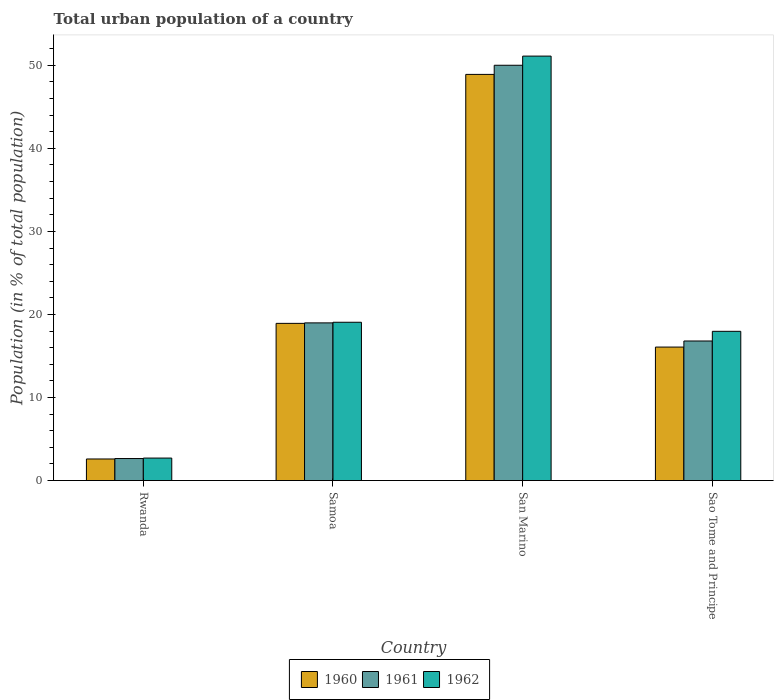How many groups of bars are there?
Your answer should be very brief. 4. How many bars are there on the 1st tick from the left?
Provide a succinct answer. 3. How many bars are there on the 4th tick from the right?
Provide a succinct answer. 3. What is the label of the 2nd group of bars from the left?
Your answer should be compact. Samoa. In how many cases, is the number of bars for a given country not equal to the number of legend labels?
Ensure brevity in your answer.  0. What is the urban population in 1962 in Samoa?
Give a very brief answer. 19.06. Across all countries, what is the maximum urban population in 1960?
Your response must be concise. 48.9. Across all countries, what is the minimum urban population in 1961?
Your response must be concise. 2.65. In which country was the urban population in 1960 maximum?
Keep it short and to the point. San Marino. In which country was the urban population in 1960 minimum?
Keep it short and to the point. Rwanda. What is the total urban population in 1960 in the graph?
Give a very brief answer. 86.5. What is the difference between the urban population in 1962 in Samoa and that in Sao Tome and Principe?
Your response must be concise. 1.09. What is the difference between the urban population in 1962 in Samoa and the urban population in 1961 in Rwanda?
Offer a terse response. 16.41. What is the average urban population in 1962 per country?
Keep it short and to the point. 22.71. What is the difference between the urban population of/in 1961 and urban population of/in 1962 in San Marino?
Give a very brief answer. -1.1. What is the ratio of the urban population in 1960 in Samoa to that in Sao Tome and Principe?
Your response must be concise. 1.18. Is the difference between the urban population in 1961 in Rwanda and Sao Tome and Principe greater than the difference between the urban population in 1962 in Rwanda and Sao Tome and Principe?
Keep it short and to the point. Yes. What is the difference between the highest and the second highest urban population in 1961?
Offer a very short reply. -33.2. What is the difference between the highest and the lowest urban population in 1960?
Ensure brevity in your answer.  46.3. Is the sum of the urban population in 1961 in Rwanda and Sao Tome and Principe greater than the maximum urban population in 1962 across all countries?
Ensure brevity in your answer.  No. What does the 3rd bar from the left in Sao Tome and Principe represents?
Your response must be concise. 1962. Does the graph contain any zero values?
Offer a very short reply. No. Does the graph contain grids?
Your answer should be compact. No. Where does the legend appear in the graph?
Give a very brief answer. Bottom center. How many legend labels are there?
Offer a very short reply. 3. How are the legend labels stacked?
Provide a succinct answer. Horizontal. What is the title of the graph?
Your response must be concise. Total urban population of a country. What is the label or title of the X-axis?
Your answer should be compact. Country. What is the label or title of the Y-axis?
Provide a succinct answer. Population (in % of total population). What is the Population (in % of total population) in 1960 in Rwanda?
Provide a succinct answer. 2.6. What is the Population (in % of total population) in 1961 in Rwanda?
Provide a succinct answer. 2.65. What is the Population (in % of total population) of 1962 in Rwanda?
Ensure brevity in your answer.  2.71. What is the Population (in % of total population) in 1960 in Samoa?
Keep it short and to the point. 18.93. What is the Population (in % of total population) in 1961 in Samoa?
Provide a succinct answer. 18.99. What is the Population (in % of total population) in 1962 in Samoa?
Offer a terse response. 19.06. What is the Population (in % of total population) of 1960 in San Marino?
Your response must be concise. 48.9. What is the Population (in % of total population) of 1961 in San Marino?
Make the answer very short. 50. What is the Population (in % of total population) in 1962 in San Marino?
Keep it short and to the point. 51.1. What is the Population (in % of total population) in 1960 in Sao Tome and Principe?
Provide a short and direct response. 16.07. What is the Population (in % of total population) in 1961 in Sao Tome and Principe?
Give a very brief answer. 16.8. What is the Population (in % of total population) in 1962 in Sao Tome and Principe?
Your answer should be very brief. 17.97. Across all countries, what is the maximum Population (in % of total population) of 1960?
Give a very brief answer. 48.9. Across all countries, what is the maximum Population (in % of total population) in 1961?
Ensure brevity in your answer.  50. Across all countries, what is the maximum Population (in % of total population) in 1962?
Offer a very short reply. 51.1. Across all countries, what is the minimum Population (in % of total population) in 1961?
Keep it short and to the point. 2.65. Across all countries, what is the minimum Population (in % of total population) of 1962?
Provide a short and direct response. 2.71. What is the total Population (in % of total population) in 1960 in the graph?
Provide a short and direct response. 86.5. What is the total Population (in % of total population) in 1961 in the graph?
Provide a succinct answer. 88.45. What is the total Population (in % of total population) of 1962 in the graph?
Make the answer very short. 90.84. What is the difference between the Population (in % of total population) of 1960 in Rwanda and that in Samoa?
Provide a short and direct response. -16.33. What is the difference between the Population (in % of total population) in 1961 in Rwanda and that in Samoa?
Your response must be concise. -16.33. What is the difference between the Population (in % of total population) in 1962 in Rwanda and that in Samoa?
Offer a terse response. -16.35. What is the difference between the Population (in % of total population) of 1960 in Rwanda and that in San Marino?
Provide a short and direct response. -46.3. What is the difference between the Population (in % of total population) of 1961 in Rwanda and that in San Marino?
Your response must be concise. -47.35. What is the difference between the Population (in % of total population) in 1962 in Rwanda and that in San Marino?
Your response must be concise. -48.39. What is the difference between the Population (in % of total population) of 1960 in Rwanda and that in Sao Tome and Principe?
Your response must be concise. -13.47. What is the difference between the Population (in % of total population) in 1961 in Rwanda and that in Sao Tome and Principe?
Your response must be concise. -14.15. What is the difference between the Population (in % of total population) of 1962 in Rwanda and that in Sao Tome and Principe?
Provide a short and direct response. -15.26. What is the difference between the Population (in % of total population) in 1960 in Samoa and that in San Marino?
Make the answer very short. -29.97. What is the difference between the Population (in % of total population) of 1961 in Samoa and that in San Marino?
Keep it short and to the point. -31.02. What is the difference between the Population (in % of total population) of 1962 in Samoa and that in San Marino?
Your answer should be very brief. -32.04. What is the difference between the Population (in % of total population) in 1960 in Samoa and that in Sao Tome and Principe?
Your answer should be compact. 2.85. What is the difference between the Population (in % of total population) in 1961 in Samoa and that in Sao Tome and Principe?
Your answer should be very brief. 2.18. What is the difference between the Population (in % of total population) in 1962 in Samoa and that in Sao Tome and Principe?
Give a very brief answer. 1.09. What is the difference between the Population (in % of total population) in 1960 in San Marino and that in Sao Tome and Principe?
Provide a succinct answer. 32.83. What is the difference between the Population (in % of total population) in 1961 in San Marino and that in Sao Tome and Principe?
Provide a short and direct response. 33.2. What is the difference between the Population (in % of total population) in 1962 in San Marino and that in Sao Tome and Principe?
Ensure brevity in your answer.  33.13. What is the difference between the Population (in % of total population) of 1960 in Rwanda and the Population (in % of total population) of 1961 in Samoa?
Keep it short and to the point. -16.39. What is the difference between the Population (in % of total population) of 1960 in Rwanda and the Population (in % of total population) of 1962 in Samoa?
Offer a terse response. -16.46. What is the difference between the Population (in % of total population) in 1961 in Rwanda and the Population (in % of total population) in 1962 in Samoa?
Your response must be concise. -16.41. What is the difference between the Population (in % of total population) in 1960 in Rwanda and the Population (in % of total population) in 1961 in San Marino?
Offer a very short reply. -47.4. What is the difference between the Population (in % of total population) in 1960 in Rwanda and the Population (in % of total population) in 1962 in San Marino?
Provide a succinct answer. -48.5. What is the difference between the Population (in % of total population) in 1961 in Rwanda and the Population (in % of total population) in 1962 in San Marino?
Provide a short and direct response. -48.45. What is the difference between the Population (in % of total population) in 1960 in Rwanda and the Population (in % of total population) in 1961 in Sao Tome and Principe?
Provide a succinct answer. -14.21. What is the difference between the Population (in % of total population) in 1960 in Rwanda and the Population (in % of total population) in 1962 in Sao Tome and Principe?
Keep it short and to the point. -15.37. What is the difference between the Population (in % of total population) of 1961 in Rwanda and the Population (in % of total population) of 1962 in Sao Tome and Principe?
Your answer should be compact. -15.31. What is the difference between the Population (in % of total population) in 1960 in Samoa and the Population (in % of total population) in 1961 in San Marino?
Ensure brevity in your answer.  -31.07. What is the difference between the Population (in % of total population) in 1960 in Samoa and the Population (in % of total population) in 1962 in San Marino?
Ensure brevity in your answer.  -32.18. What is the difference between the Population (in % of total population) in 1961 in Samoa and the Population (in % of total population) in 1962 in San Marino?
Offer a terse response. -32.12. What is the difference between the Population (in % of total population) in 1960 in Samoa and the Population (in % of total population) in 1961 in Sao Tome and Principe?
Offer a terse response. 2.12. What is the difference between the Population (in % of total population) in 1961 in Samoa and the Population (in % of total population) in 1962 in Sao Tome and Principe?
Give a very brief answer. 1.02. What is the difference between the Population (in % of total population) in 1960 in San Marino and the Population (in % of total population) in 1961 in Sao Tome and Principe?
Offer a very short reply. 32.09. What is the difference between the Population (in % of total population) in 1960 in San Marino and the Population (in % of total population) in 1962 in Sao Tome and Principe?
Make the answer very short. 30.93. What is the difference between the Population (in % of total population) of 1961 in San Marino and the Population (in % of total population) of 1962 in Sao Tome and Principe?
Keep it short and to the point. 32.03. What is the average Population (in % of total population) in 1960 per country?
Provide a succinct answer. 21.62. What is the average Population (in % of total population) of 1961 per country?
Offer a terse response. 22.11. What is the average Population (in % of total population) in 1962 per country?
Your answer should be compact. 22.71. What is the difference between the Population (in % of total population) in 1960 and Population (in % of total population) in 1961 in Rwanda?
Ensure brevity in your answer.  -0.05. What is the difference between the Population (in % of total population) in 1960 and Population (in % of total population) in 1962 in Rwanda?
Provide a short and direct response. -0.11. What is the difference between the Population (in % of total population) in 1961 and Population (in % of total population) in 1962 in Rwanda?
Make the answer very short. -0.06. What is the difference between the Population (in % of total population) in 1960 and Population (in % of total population) in 1961 in Samoa?
Your answer should be very brief. -0.06. What is the difference between the Population (in % of total population) in 1960 and Population (in % of total population) in 1962 in Samoa?
Your response must be concise. -0.14. What is the difference between the Population (in % of total population) in 1961 and Population (in % of total population) in 1962 in Samoa?
Your response must be concise. -0.07. What is the difference between the Population (in % of total population) in 1960 and Population (in % of total population) in 1961 in San Marino?
Provide a short and direct response. -1.1. What is the difference between the Population (in % of total population) of 1960 and Population (in % of total population) of 1962 in San Marino?
Provide a short and direct response. -2.2. What is the difference between the Population (in % of total population) of 1961 and Population (in % of total population) of 1962 in San Marino?
Your answer should be compact. -1.1. What is the difference between the Population (in % of total population) in 1960 and Population (in % of total population) in 1961 in Sao Tome and Principe?
Provide a succinct answer. -0.73. What is the difference between the Population (in % of total population) in 1960 and Population (in % of total population) in 1962 in Sao Tome and Principe?
Your answer should be compact. -1.9. What is the difference between the Population (in % of total population) in 1961 and Population (in % of total population) in 1962 in Sao Tome and Principe?
Offer a terse response. -1.16. What is the ratio of the Population (in % of total population) in 1960 in Rwanda to that in Samoa?
Ensure brevity in your answer.  0.14. What is the ratio of the Population (in % of total population) in 1961 in Rwanda to that in Samoa?
Your answer should be very brief. 0.14. What is the ratio of the Population (in % of total population) of 1962 in Rwanda to that in Samoa?
Your answer should be very brief. 0.14. What is the ratio of the Population (in % of total population) in 1960 in Rwanda to that in San Marino?
Offer a very short reply. 0.05. What is the ratio of the Population (in % of total population) in 1961 in Rwanda to that in San Marino?
Ensure brevity in your answer.  0.05. What is the ratio of the Population (in % of total population) in 1962 in Rwanda to that in San Marino?
Offer a very short reply. 0.05. What is the ratio of the Population (in % of total population) in 1960 in Rwanda to that in Sao Tome and Principe?
Offer a very short reply. 0.16. What is the ratio of the Population (in % of total population) of 1961 in Rwanda to that in Sao Tome and Principe?
Your answer should be compact. 0.16. What is the ratio of the Population (in % of total population) of 1962 in Rwanda to that in Sao Tome and Principe?
Make the answer very short. 0.15. What is the ratio of the Population (in % of total population) in 1960 in Samoa to that in San Marino?
Provide a succinct answer. 0.39. What is the ratio of the Population (in % of total population) of 1961 in Samoa to that in San Marino?
Keep it short and to the point. 0.38. What is the ratio of the Population (in % of total population) in 1962 in Samoa to that in San Marino?
Give a very brief answer. 0.37. What is the ratio of the Population (in % of total population) in 1960 in Samoa to that in Sao Tome and Principe?
Your answer should be compact. 1.18. What is the ratio of the Population (in % of total population) in 1961 in Samoa to that in Sao Tome and Principe?
Provide a short and direct response. 1.13. What is the ratio of the Population (in % of total population) of 1962 in Samoa to that in Sao Tome and Principe?
Provide a succinct answer. 1.06. What is the ratio of the Population (in % of total population) of 1960 in San Marino to that in Sao Tome and Principe?
Ensure brevity in your answer.  3.04. What is the ratio of the Population (in % of total population) in 1961 in San Marino to that in Sao Tome and Principe?
Keep it short and to the point. 2.98. What is the ratio of the Population (in % of total population) of 1962 in San Marino to that in Sao Tome and Principe?
Offer a terse response. 2.84. What is the difference between the highest and the second highest Population (in % of total population) of 1960?
Provide a short and direct response. 29.97. What is the difference between the highest and the second highest Population (in % of total population) of 1961?
Keep it short and to the point. 31.02. What is the difference between the highest and the second highest Population (in % of total population) of 1962?
Give a very brief answer. 32.04. What is the difference between the highest and the lowest Population (in % of total population) in 1960?
Provide a short and direct response. 46.3. What is the difference between the highest and the lowest Population (in % of total population) in 1961?
Your answer should be very brief. 47.35. What is the difference between the highest and the lowest Population (in % of total population) in 1962?
Offer a very short reply. 48.39. 